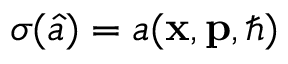Convert formula to latex. <formula><loc_0><loc_0><loc_500><loc_500>\sigma ( \hat { a } ) = a ( x , p , \hbar { ) }</formula> 